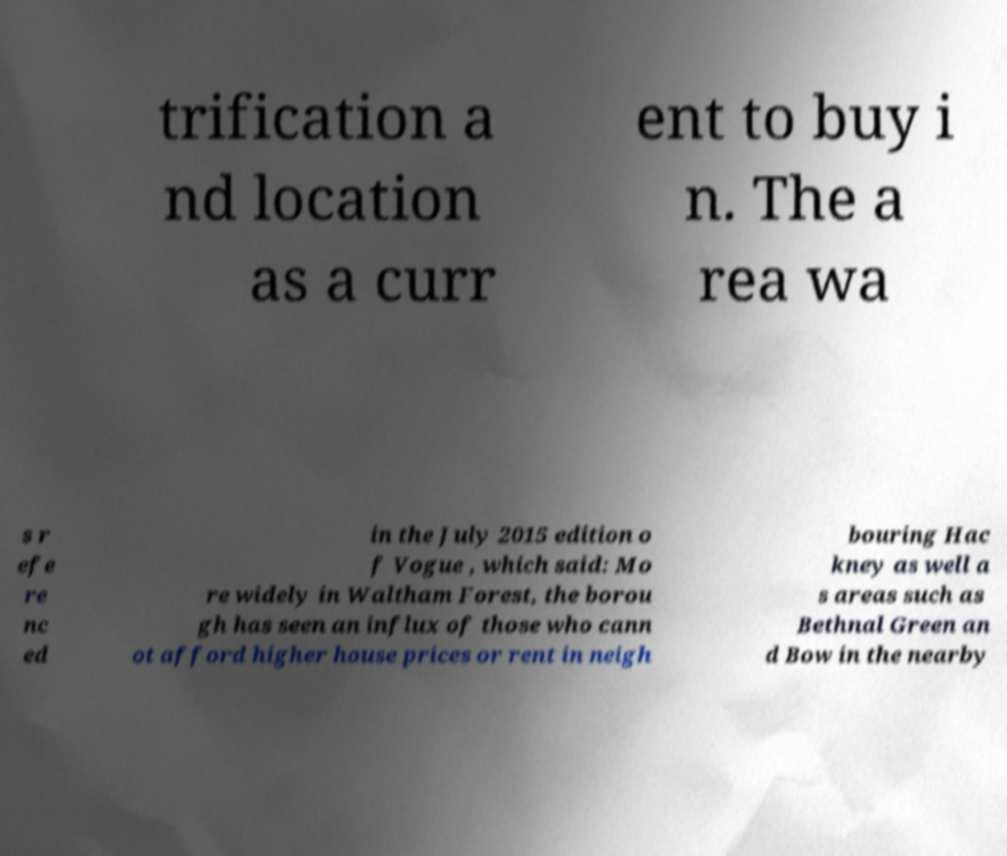Can you read and provide the text displayed in the image?This photo seems to have some interesting text. Can you extract and type it out for me? trification a nd location as a curr ent to buy i n. The a rea wa s r efe re nc ed in the July 2015 edition o f Vogue , which said: Mo re widely in Waltham Forest, the borou gh has seen an influx of those who cann ot afford higher house prices or rent in neigh bouring Hac kney as well a s areas such as Bethnal Green an d Bow in the nearby 